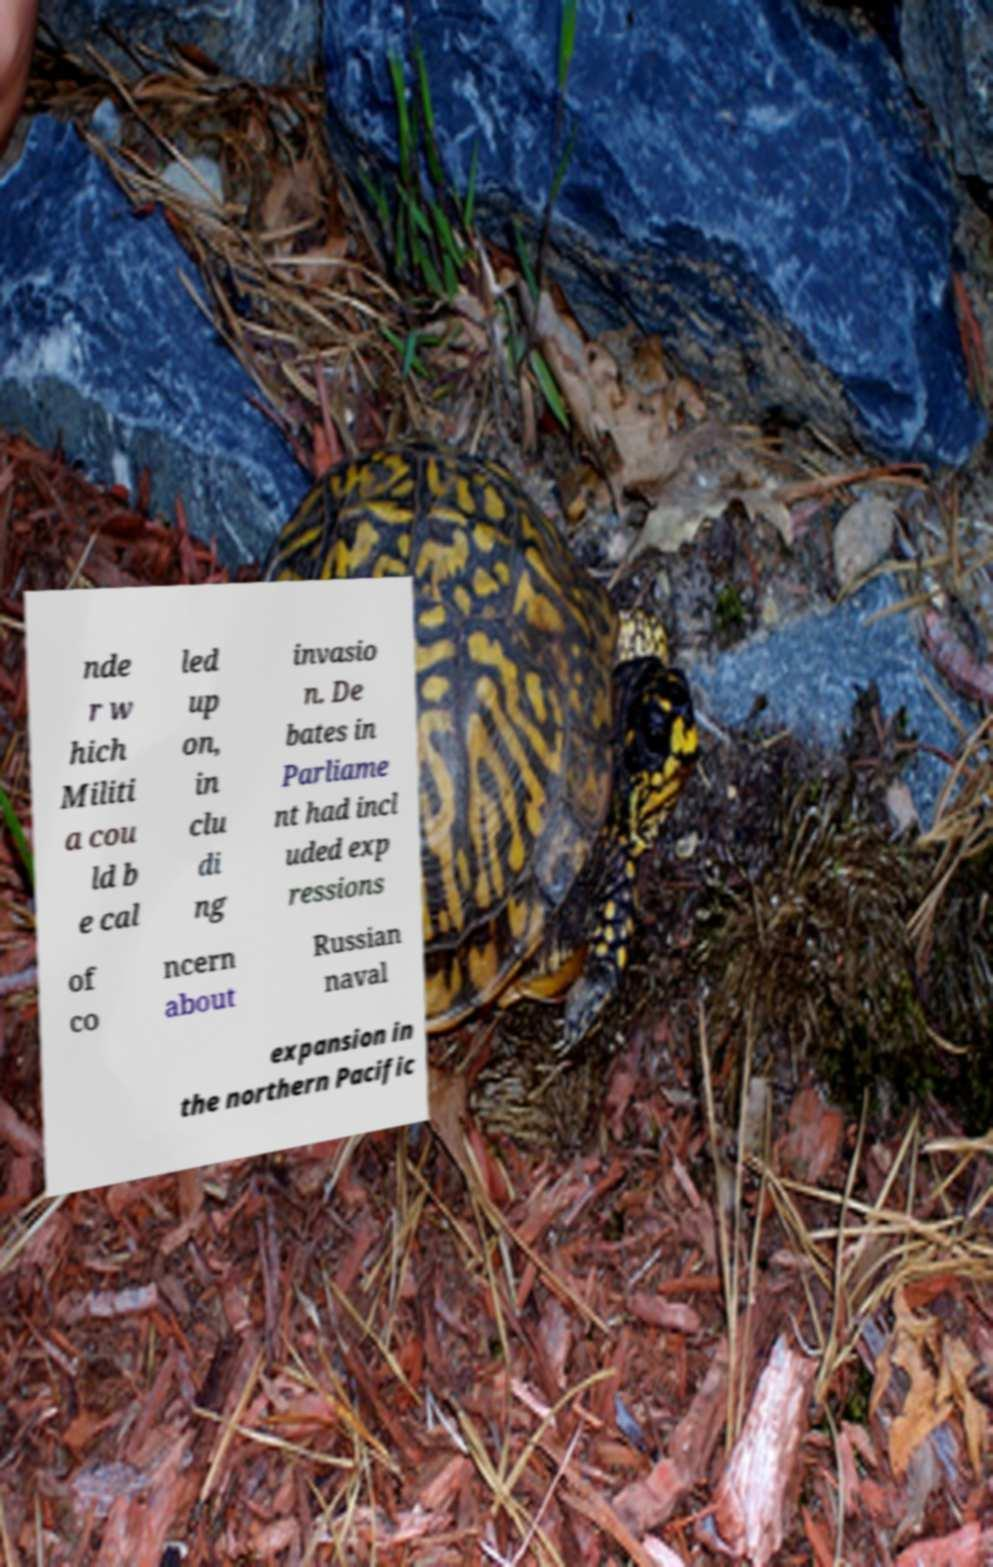Please read and relay the text visible in this image. What does it say? nde r w hich Militi a cou ld b e cal led up on, in clu di ng invasio n. De bates in Parliame nt had incl uded exp ressions of co ncern about Russian naval expansion in the northern Pacific 